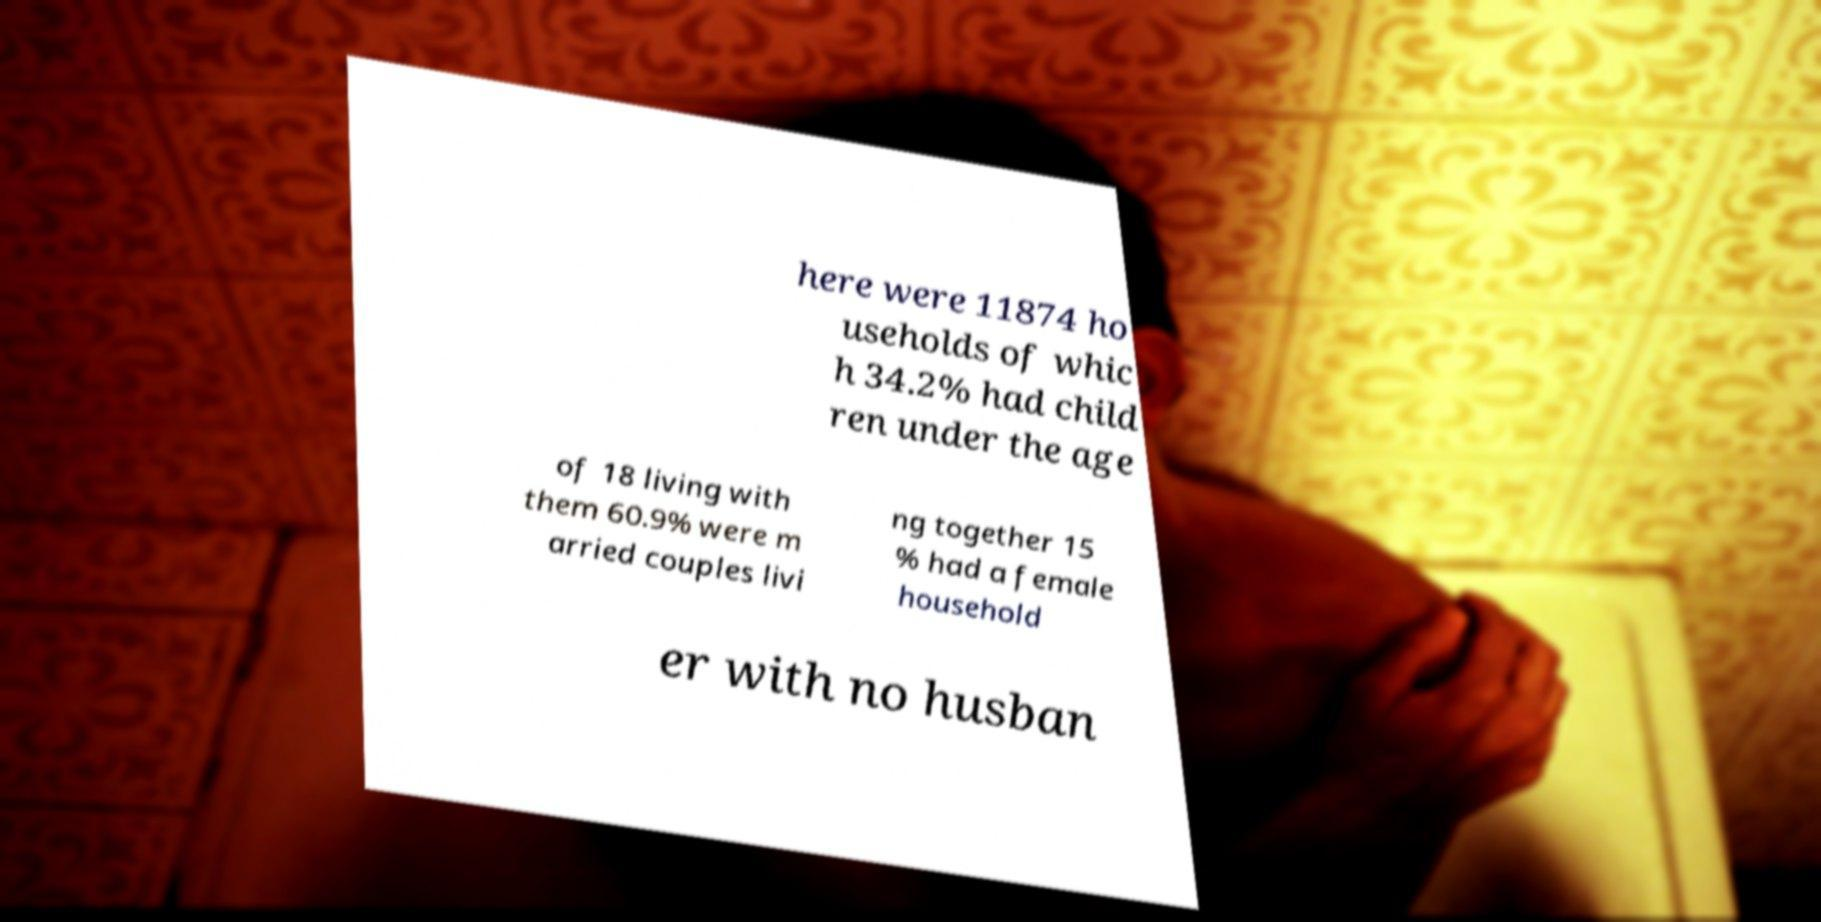What messages or text are displayed in this image? I need them in a readable, typed format. here were 11874 ho useholds of whic h 34.2% had child ren under the age of 18 living with them 60.9% were m arried couples livi ng together 15 % had a female household er with no husban 